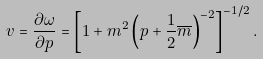Convert formula to latex. <formula><loc_0><loc_0><loc_500><loc_500>v = \frac { \partial \omega } { \partial p } = \left [ 1 + m ^ { 2 } \left ( p + \frac { 1 } { 2 } \overline { m } \right ) ^ { - 2 } \right ] ^ { - 1 / 2 } .</formula> 